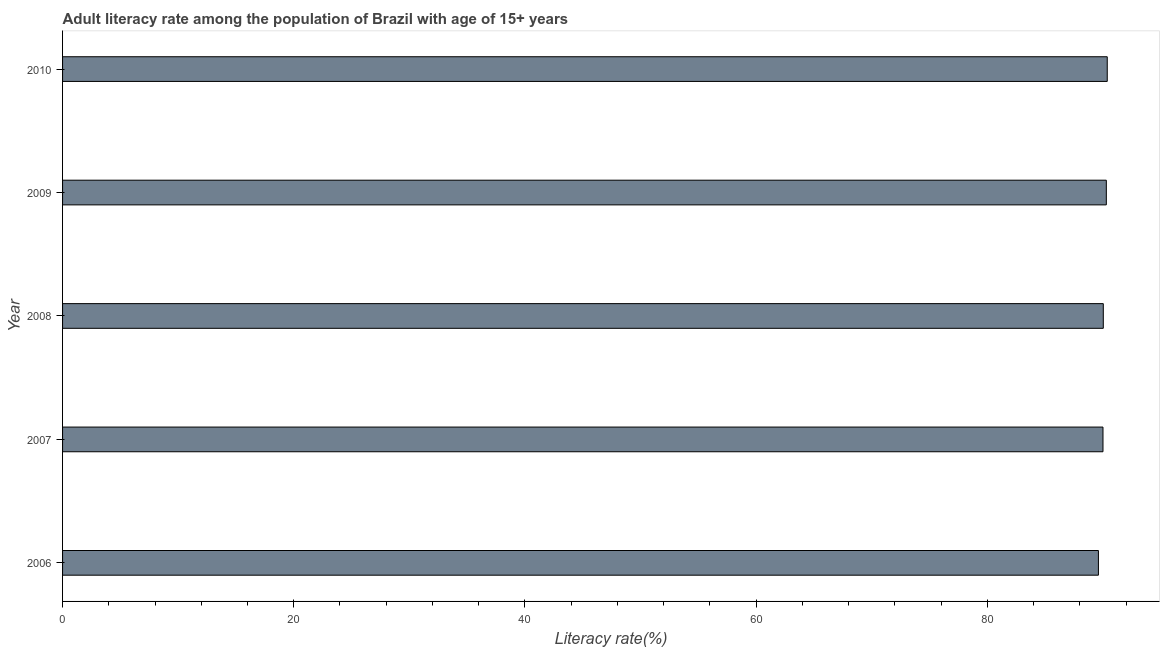Does the graph contain any zero values?
Your answer should be compact. No. Does the graph contain grids?
Your answer should be very brief. No. What is the title of the graph?
Provide a succinct answer. Adult literacy rate among the population of Brazil with age of 15+ years. What is the label or title of the X-axis?
Your answer should be very brief. Literacy rate(%). What is the label or title of the Y-axis?
Provide a short and direct response. Year. What is the adult literacy rate in 2009?
Offer a terse response. 90.3. Across all years, what is the maximum adult literacy rate?
Offer a terse response. 90.38. Across all years, what is the minimum adult literacy rate?
Make the answer very short. 89.62. What is the sum of the adult literacy rate?
Your answer should be very brief. 450.34. What is the difference between the adult literacy rate in 2006 and 2008?
Ensure brevity in your answer.  -0.42. What is the average adult literacy rate per year?
Offer a terse response. 90.07. What is the median adult literacy rate?
Your answer should be compact. 90.04. Do a majority of the years between 2006 and 2010 (inclusive) have adult literacy rate greater than 28 %?
Your answer should be very brief. Yes. Is the adult literacy rate in 2007 less than that in 2009?
Ensure brevity in your answer.  Yes. Is the difference between the adult literacy rate in 2007 and 2010 greater than the difference between any two years?
Give a very brief answer. No. What is the difference between the highest and the second highest adult literacy rate?
Provide a short and direct response. 0.08. What is the difference between the highest and the lowest adult literacy rate?
Make the answer very short. 0.76. In how many years, is the adult literacy rate greater than the average adult literacy rate taken over all years?
Give a very brief answer. 2. Are all the bars in the graph horizontal?
Give a very brief answer. Yes. What is the difference between two consecutive major ticks on the X-axis?
Ensure brevity in your answer.  20. Are the values on the major ticks of X-axis written in scientific E-notation?
Ensure brevity in your answer.  No. What is the Literacy rate(%) in 2006?
Your response must be concise. 89.62. What is the Literacy rate(%) in 2007?
Ensure brevity in your answer.  90.01. What is the Literacy rate(%) in 2008?
Offer a very short reply. 90.04. What is the Literacy rate(%) of 2009?
Keep it short and to the point. 90.3. What is the Literacy rate(%) in 2010?
Provide a short and direct response. 90.38. What is the difference between the Literacy rate(%) in 2006 and 2007?
Your answer should be compact. -0.39. What is the difference between the Literacy rate(%) in 2006 and 2008?
Your answer should be very brief. -0.42. What is the difference between the Literacy rate(%) in 2006 and 2009?
Offer a very short reply. -0.68. What is the difference between the Literacy rate(%) in 2006 and 2010?
Make the answer very short. -0.76. What is the difference between the Literacy rate(%) in 2007 and 2008?
Offer a very short reply. -0.03. What is the difference between the Literacy rate(%) in 2007 and 2009?
Ensure brevity in your answer.  -0.29. What is the difference between the Literacy rate(%) in 2007 and 2010?
Offer a very short reply. -0.37. What is the difference between the Literacy rate(%) in 2008 and 2009?
Provide a short and direct response. -0.26. What is the difference between the Literacy rate(%) in 2008 and 2010?
Offer a terse response. -0.34. What is the difference between the Literacy rate(%) in 2009 and 2010?
Give a very brief answer. -0.08. What is the ratio of the Literacy rate(%) in 2006 to that in 2007?
Offer a terse response. 1. What is the ratio of the Literacy rate(%) in 2006 to that in 2008?
Provide a short and direct response. 0.99. What is the ratio of the Literacy rate(%) in 2007 to that in 2009?
Make the answer very short. 1. What is the ratio of the Literacy rate(%) in 2008 to that in 2010?
Your answer should be compact. 1. 